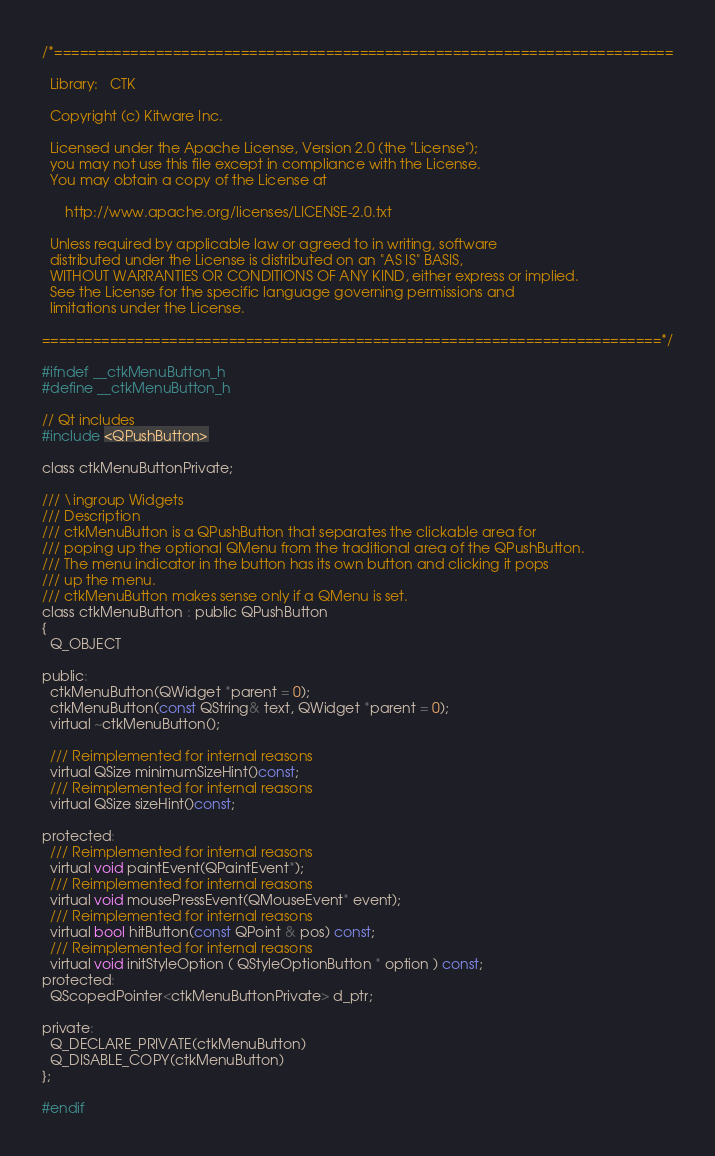Convert code to text. <code><loc_0><loc_0><loc_500><loc_500><_C_>/*=========================================================================

  Library:   CTK

  Copyright (c) Kitware Inc.

  Licensed under the Apache License, Version 2.0 (the "License");
  you may not use this file except in compliance with the License.
  You may obtain a copy of the License at

      http://www.apache.org/licenses/LICENSE-2.0.txt

  Unless required by applicable law or agreed to in writing, software
  distributed under the License is distributed on an "AS IS" BASIS,
  WITHOUT WARRANTIES OR CONDITIONS OF ANY KIND, either express or implied.
  See the License for the specific language governing permissions and
  limitations under the License.

=========================================================================*/

#ifndef __ctkMenuButton_h
#define __ctkMenuButton_h

// Qt includes
#include <QPushButton>

class ctkMenuButtonPrivate;

/// \ingroup Widgets
/// Description
/// ctkMenuButton is a QPushButton that separates the clickable area for
/// poping up the optional QMenu from the traditional area of the QPushButton.
/// The menu indicator in the button has its own button and clicking it pops
/// up the menu.
/// ctkMenuButton makes sense only if a QMenu is set.
class ctkMenuButton : public QPushButton
{
  Q_OBJECT

public:
  ctkMenuButton(QWidget *parent = 0);
  ctkMenuButton(const QString& text, QWidget *parent = 0);
  virtual ~ctkMenuButton();

  /// Reimplemented for internal reasons
  virtual QSize minimumSizeHint()const;
  /// Reimplemented for internal reasons
  virtual QSize sizeHint()const;

protected:
  /// Reimplemented for internal reasons
  virtual void paintEvent(QPaintEvent*);
  /// Reimplemented for internal reasons
  virtual void mousePressEvent(QMouseEvent* event);
  /// Reimplemented for internal reasons
  virtual bool hitButton(const QPoint & pos) const;
  /// Reimplemented for internal reasons
  virtual void initStyleOption ( QStyleOptionButton * option ) const;
protected:
  QScopedPointer<ctkMenuButtonPrivate> d_ptr;

private:
  Q_DECLARE_PRIVATE(ctkMenuButton)
  Q_DISABLE_COPY(ctkMenuButton)
};

#endif
</code> 